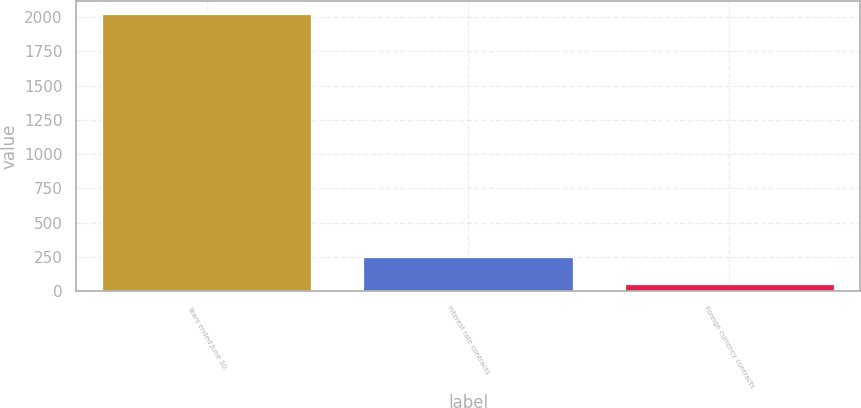Convert chart to OTSL. <chart><loc_0><loc_0><loc_500><loc_500><bar_chart><fcel>Years ended June 30<fcel>Interest rate contracts<fcel>Foreign currency contracts<nl><fcel>2019<fcel>250.5<fcel>54<nl></chart> 